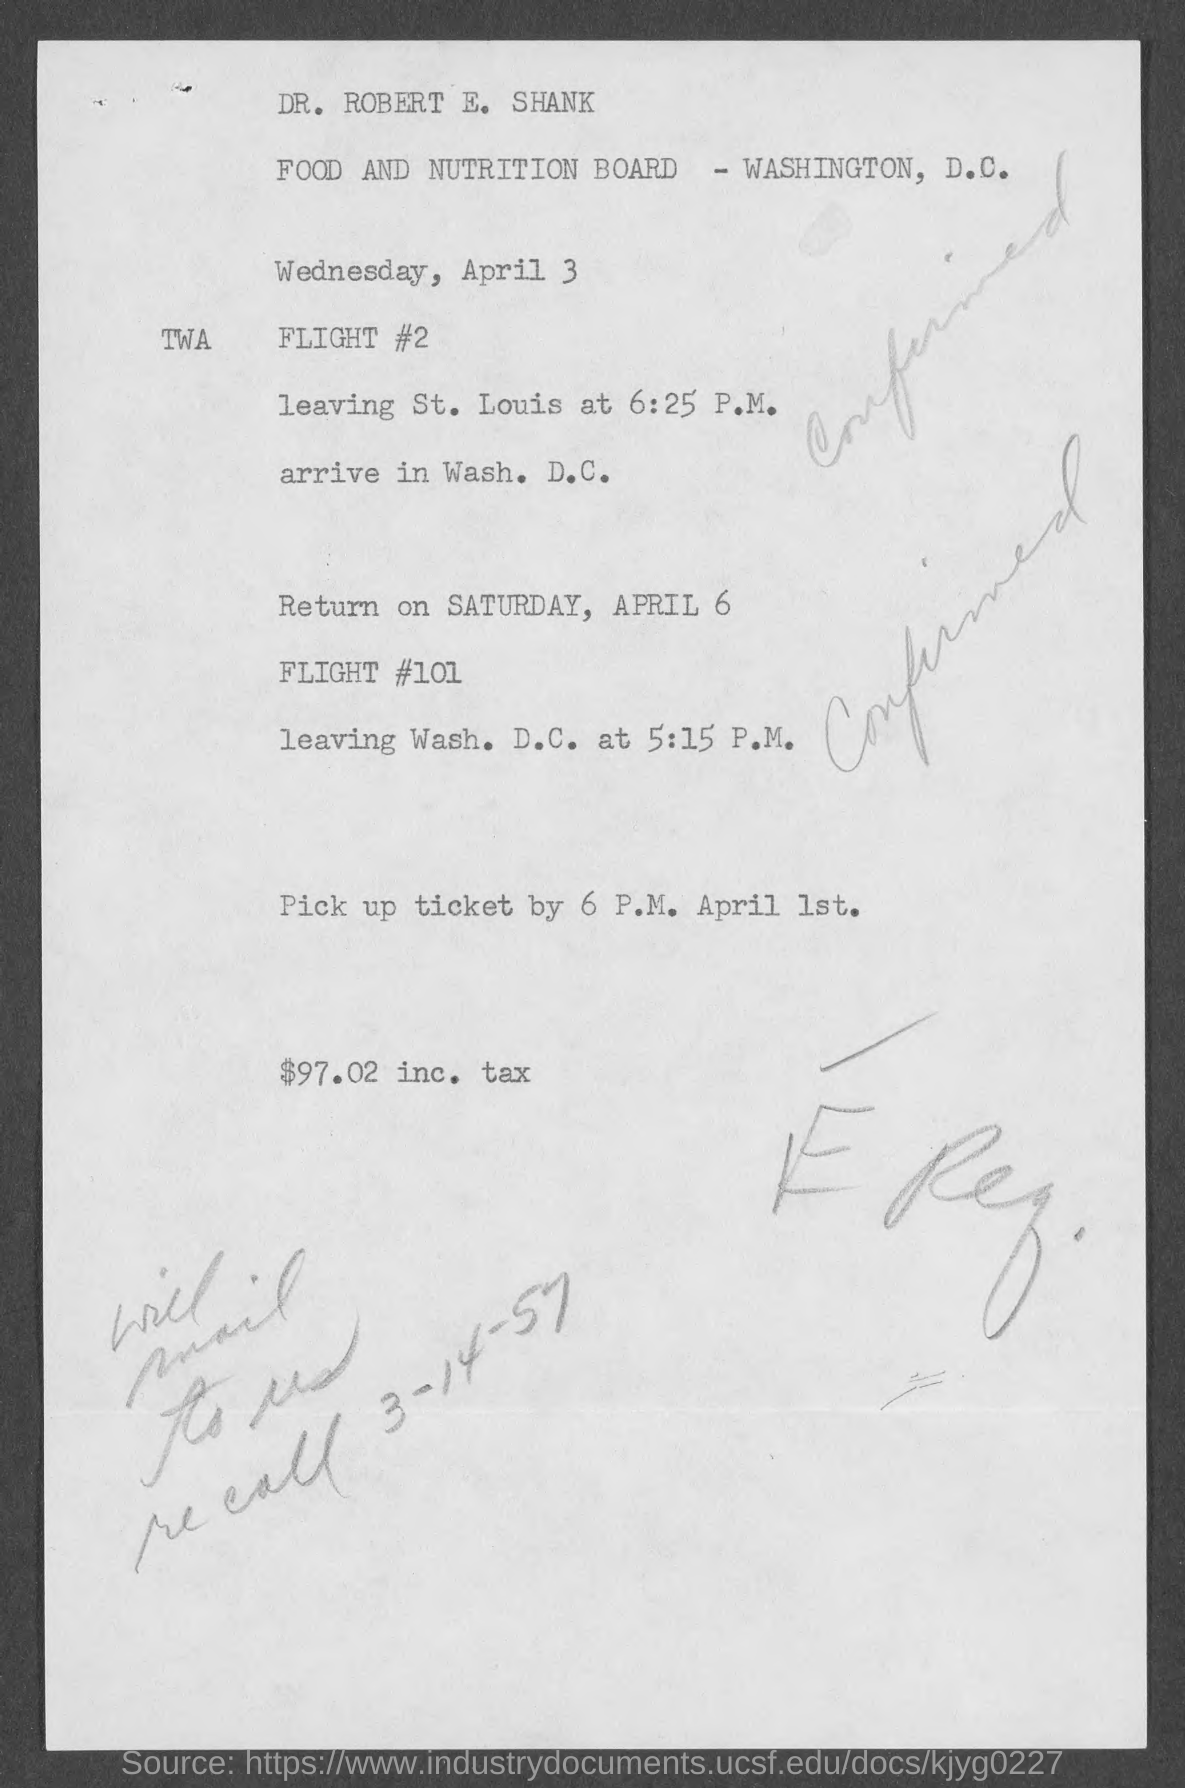List a handful of essential elements in this visual. The return flight is scheduled for Saturday, April 6. The return flight number is 101. The amount including tax is $97.02. FLIGHT #2 will leave St. Louis at 6:25 p.m. 